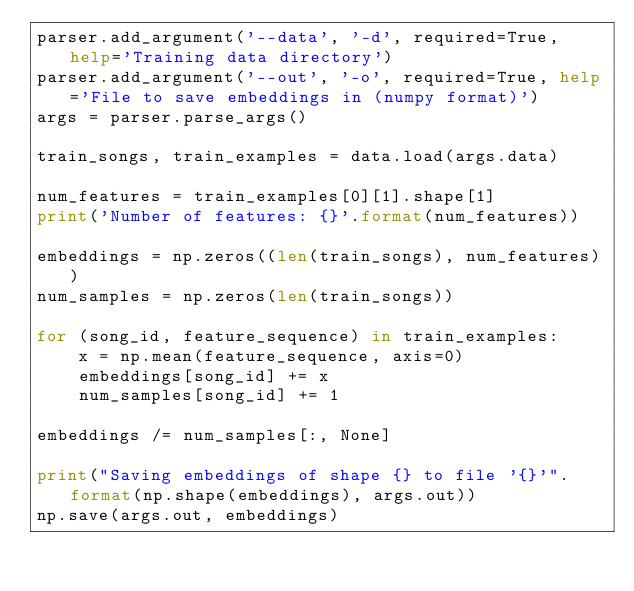<code> <loc_0><loc_0><loc_500><loc_500><_Python_>parser.add_argument('--data', '-d', required=True, help='Training data directory')
parser.add_argument('--out', '-o', required=True, help='File to save embeddings in (numpy format)')
args = parser.parse_args()

train_songs, train_examples = data.load(args.data)

num_features = train_examples[0][1].shape[1]
print('Number of features: {}'.format(num_features))

embeddings = np.zeros((len(train_songs), num_features))
num_samples = np.zeros(len(train_songs))

for (song_id, feature_sequence) in train_examples:
    x = np.mean(feature_sequence, axis=0)
    embeddings[song_id] += x
    num_samples[song_id] += 1

embeddings /= num_samples[:, None]

print("Saving embeddings of shape {} to file '{}'".format(np.shape(embeddings), args.out))
np.save(args.out, embeddings)
</code> 